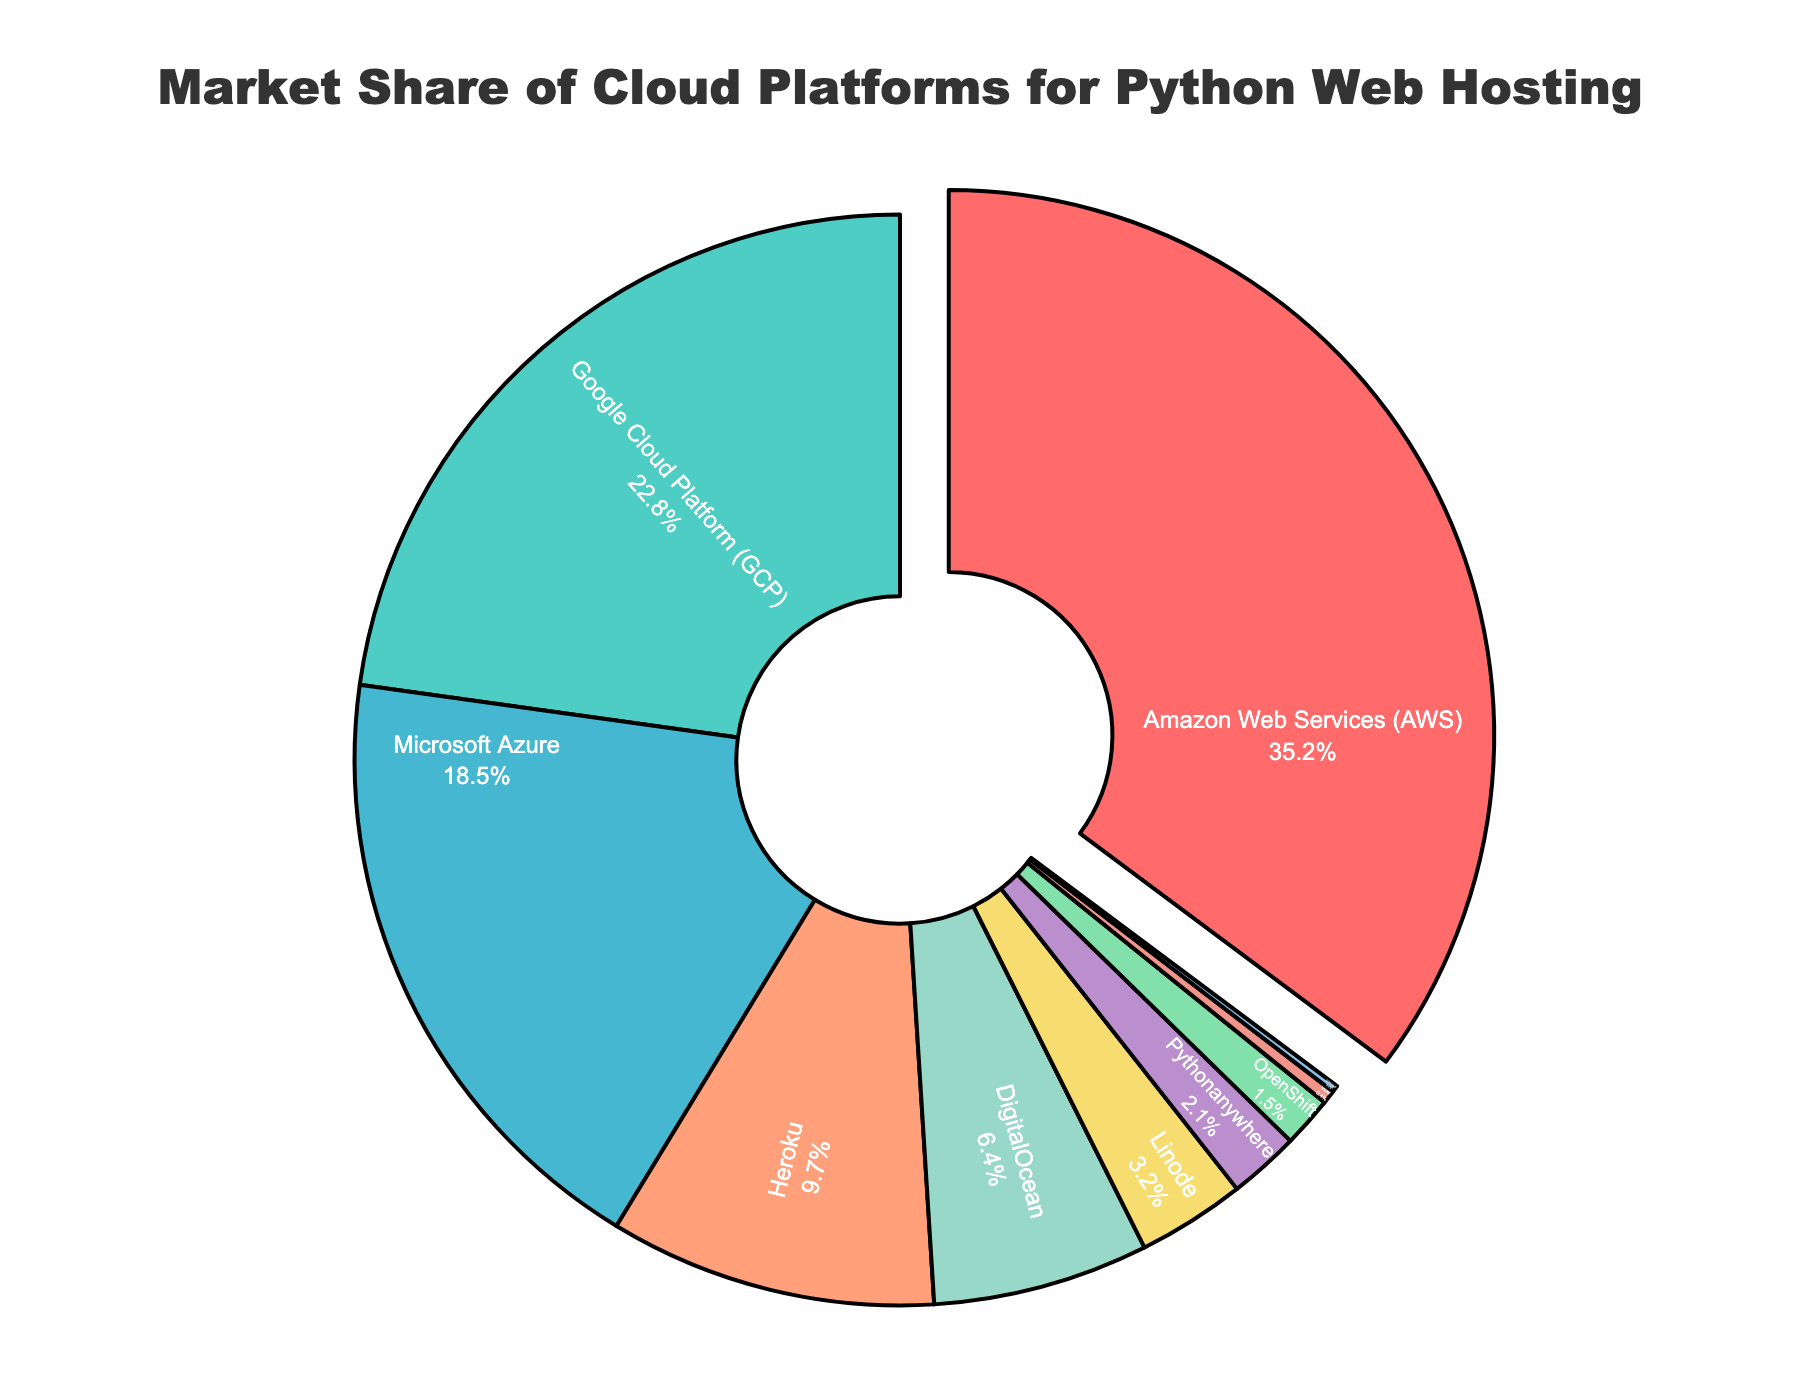What is the market share of Amazon Web Services (AWS)? The chart shows the market share of each cloud platform, with AWS holding the largest share. By looking directly at the labels on the pie chart, we can see the market share of AWS.
Answer: 35.2% Which cloud provider has the second-largest market share? By examining the pie chart, we can see the labels and percentages associated with each segment. The second-largest share is labeled as Google Cloud Platform (GCP).
Answer: Google Cloud Platform (GCP) How much larger is the market share of AWS compared to Microsoft Azure? The market share of AWS is 35.2%, and the market share of Microsoft Azure is 18.5%. By subtracting Azure's share from AWS's share, 35.2% - 18.5%, we can find the difference.
Answer: 16.7% What is the combined market share of Heroku, DigitalOcean, and Linode? The market shares for Heroku, DigitalOcean, and Linode are 9.7%, 6.4%, and 3.2% respectively. Summing these values gives 9.7% + 6.4% + 3.2% = 19.3%.
Answer: 19.3% Which cloud provider has the smallest market share, and what is that share? The segment with the smallest percentage label belongs to OVHcloud. By locating the smallest slice in the pie chart, we can see OVHcloud's market share.
Answer: OVHcloud, 0.2% How many providers have a market share greater than 10%? By examining the pie chart, we can count the segments labeled with percentages greater than 10%. AWS, GCP, and Microsoft Azure all have shares greater than 10%.
Answer: 3 Which cloud provider is represented by the green color in the pie chart? By looking at the colors used in the pie chart, the green segment corresponds to the label 'Google Cloud Platform (GCP)'.
Answer: Google Cloud Platform (GCP) What is the difference in market share between DigitalOcean and Pythonanywhere? The market share of DigitalOcean is 6.4% and Pythonanywhere is 2.1%. Subtracting Pythonanywhere's share from DigitalOcean's share, 6.4% - 2.1%, gives the difference.
Answer: 4.3% What percentage of the total market share is held by providers with less than 5% market share each? Providers with less than 5% market share are Linode (3.2%), Pythonanywhere (2.1%), OpenShift (1.5%), Vultr (0.4%), and OVHcloud (0.2%). Adding these gives 3.2% + 2.1% + 1.5% + 0.4% + 0.2% = 7.4%.
Answer: 7.4% What is the combined market share of AWS, GCP, and Microsoft Azure? AWS has a market share of 35.2%, GCP has 22.8%, and Microsoft Azure has 18.5%. Adding these values gives 35.2% + 22.8% + 18.5% = 76.5%.
Answer: 76.5% 